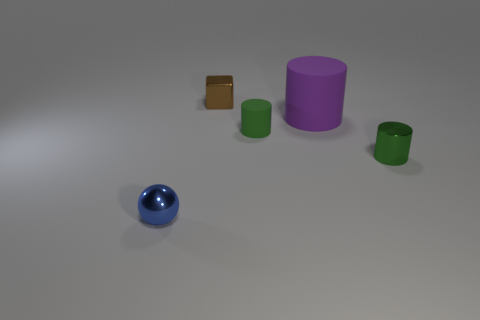How many small things are both on the left side of the large purple matte cylinder and on the right side of the shiny cube?
Offer a terse response. 1. What is the object that is in front of the tiny green matte cylinder and on the right side of the tiny brown metallic cube made of?
Provide a succinct answer. Metal. Are there fewer large purple things that are in front of the small blue sphere than things that are in front of the purple matte object?
Your answer should be very brief. Yes. There is a ball that is the same material as the brown thing; what is its size?
Provide a short and direct response. Small. Are there any other things that are the same color as the large rubber cylinder?
Offer a very short reply. No. Does the purple object have the same material as the tiny green cylinder that is on the left side of the green shiny cylinder?
Offer a terse response. Yes. There is another small green object that is the same shape as the small matte object; what is its material?
Provide a succinct answer. Metal. Are the small object to the right of the purple rubber thing and the small green thing left of the purple object made of the same material?
Provide a short and direct response. No. What color is the thing that is in front of the object that is to the right of the purple thing that is in front of the cube?
Offer a very short reply. Blue. What number of other objects are there of the same shape as the tiny rubber object?
Provide a short and direct response. 2. 